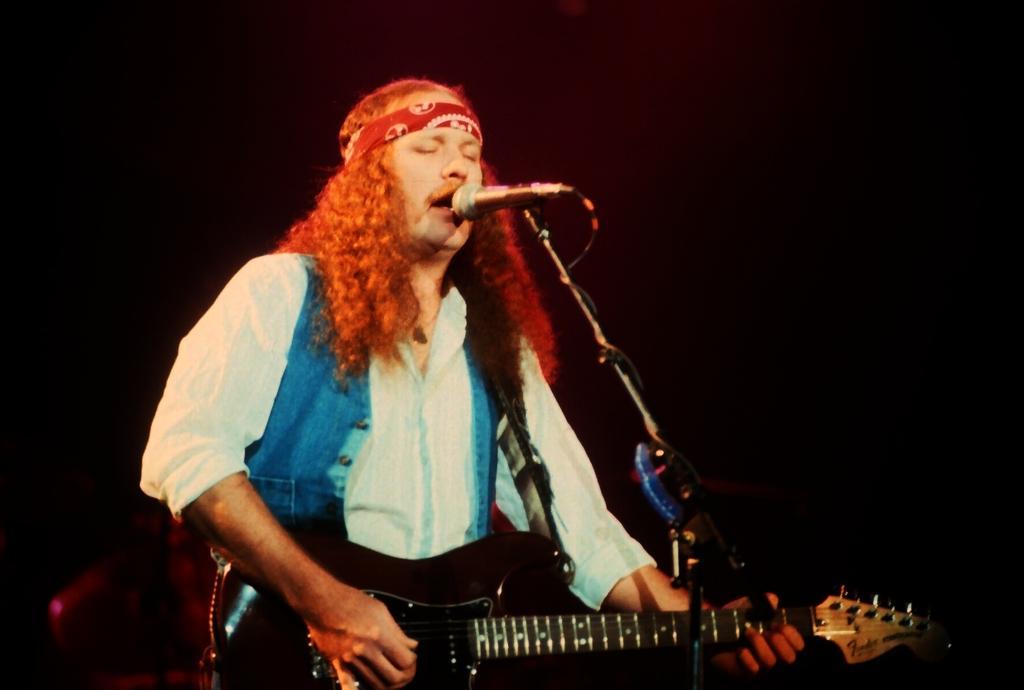Could you give a brief overview of what you see in this image? In this image in the center there is one person who is standing and he is holding a guitar, in front of him there is one mike it seems that he is singing. In the background there is a wall. 